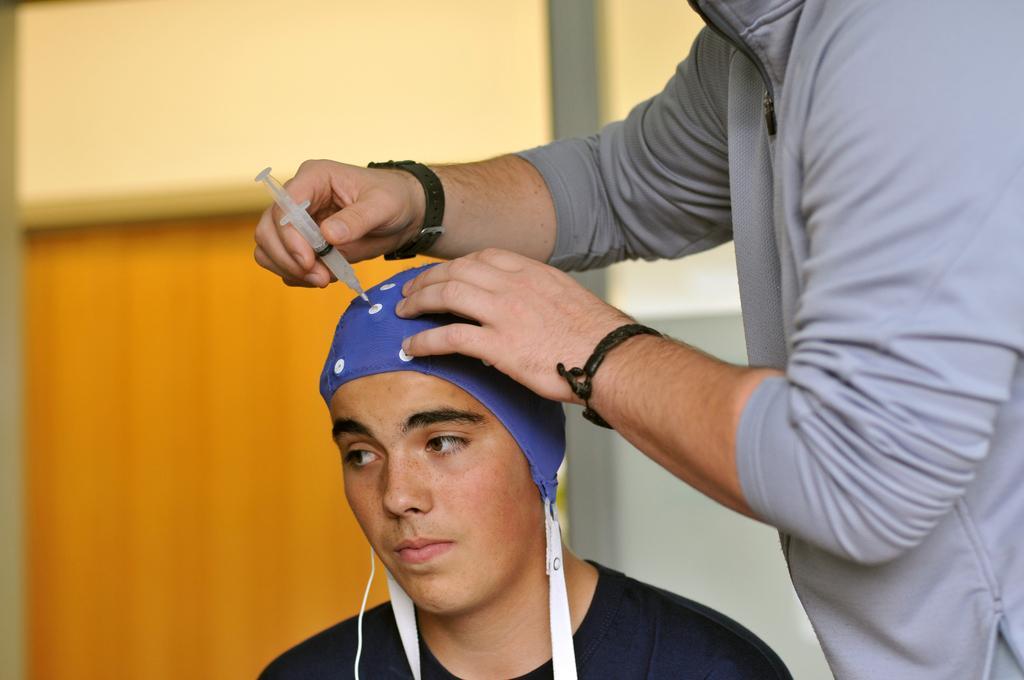Describe this image in one or two sentences. In this picture I can observe two persons. One of them is holding an injection in his hand. The background is blurred. 